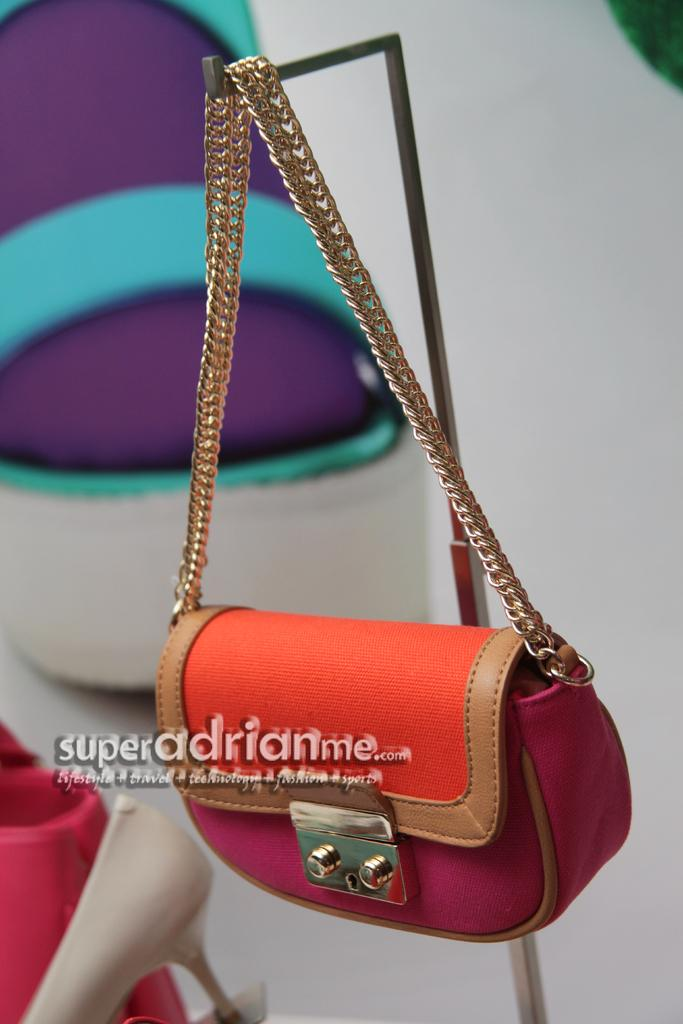What is hanging on a stand in the image? There is a handbag hanging on a stand in the image. What part of the body can be seen on a table in the image? There is a foot on a table in the image. What type of angle is the girl using to measure the salt in the image? There is no girl or salt present in the image, so this question cannot be answered. 